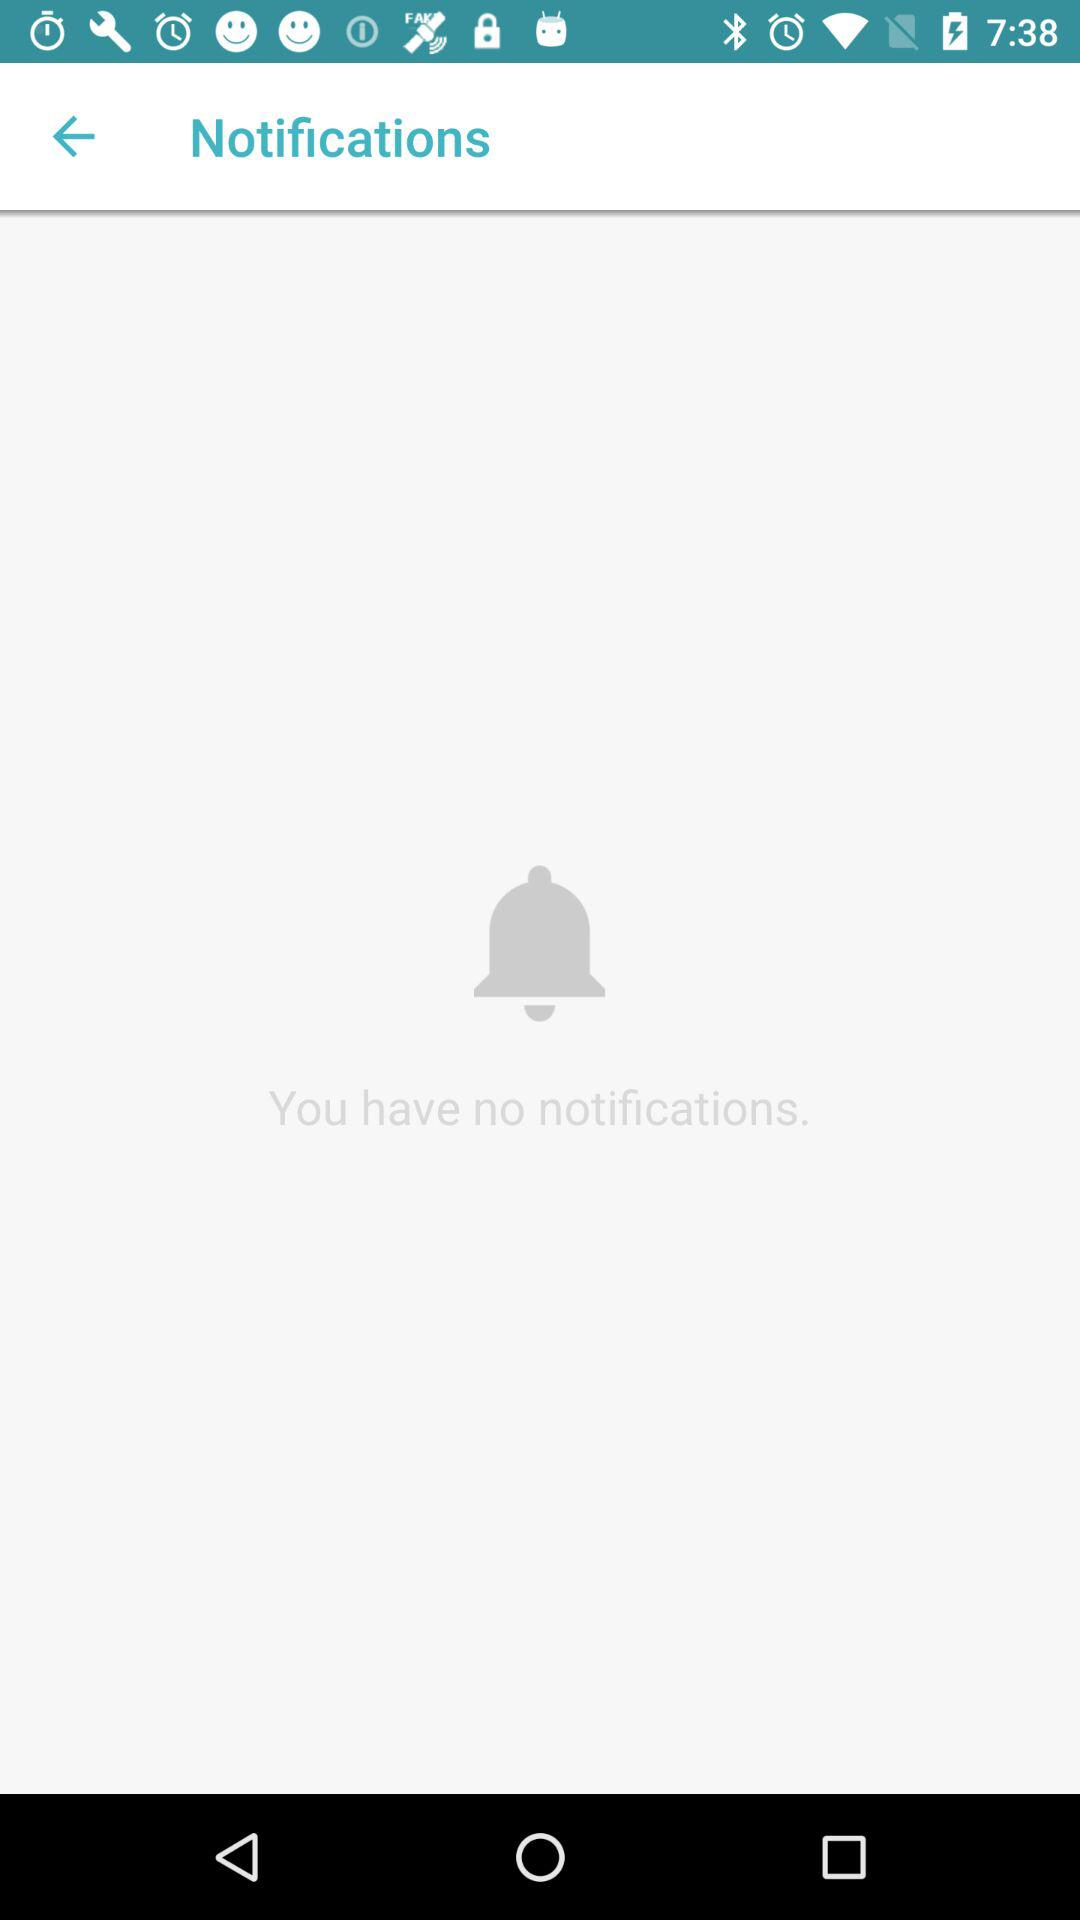How many notifications are there?
When the provided information is insufficient, respond with <no answer>. <no answer> 